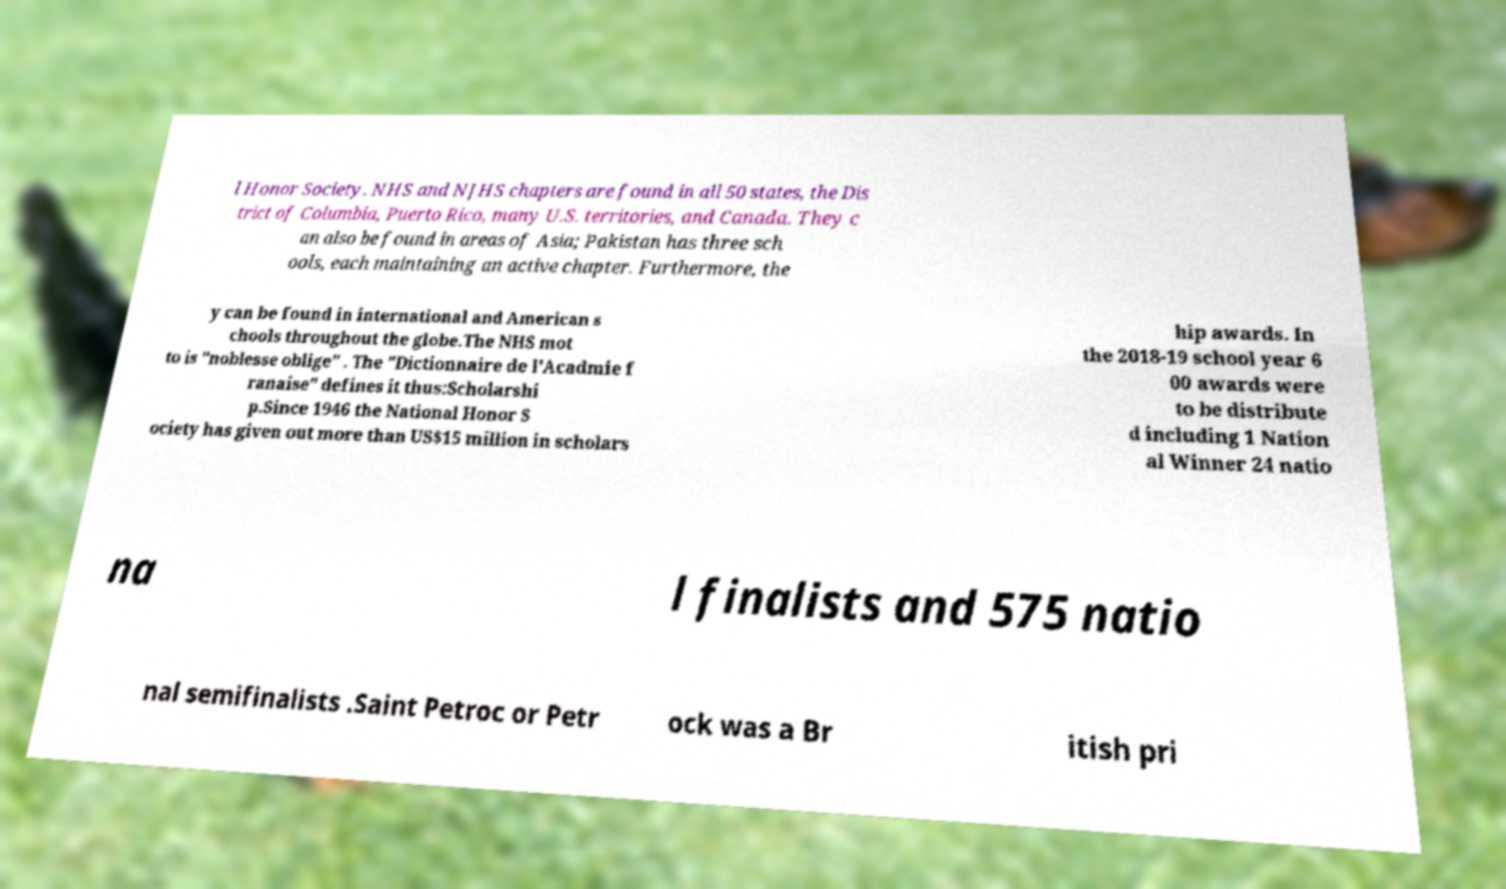What messages or text are displayed in this image? I need them in a readable, typed format. l Honor Society. NHS and NJHS chapters are found in all 50 states, the Dis trict of Columbia, Puerto Rico, many U.S. territories, and Canada. They c an also be found in areas of Asia; Pakistan has three sch ools, each maintaining an active chapter. Furthermore, the y can be found in international and American s chools throughout the globe.The NHS mot to is "noblesse oblige" . The "Dictionnaire de l'Acadmie f ranaise" defines it thus:Scholarshi p.Since 1946 the National Honor S ociety has given out more than US$15 million in scholars hip awards. In the 2018-19 school year 6 00 awards were to be distribute d including 1 Nation al Winner 24 natio na l finalists and 575 natio nal semifinalists .Saint Petroc or Petr ock was a Br itish pri 